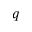<formula> <loc_0><loc_0><loc_500><loc_500>q</formula> 